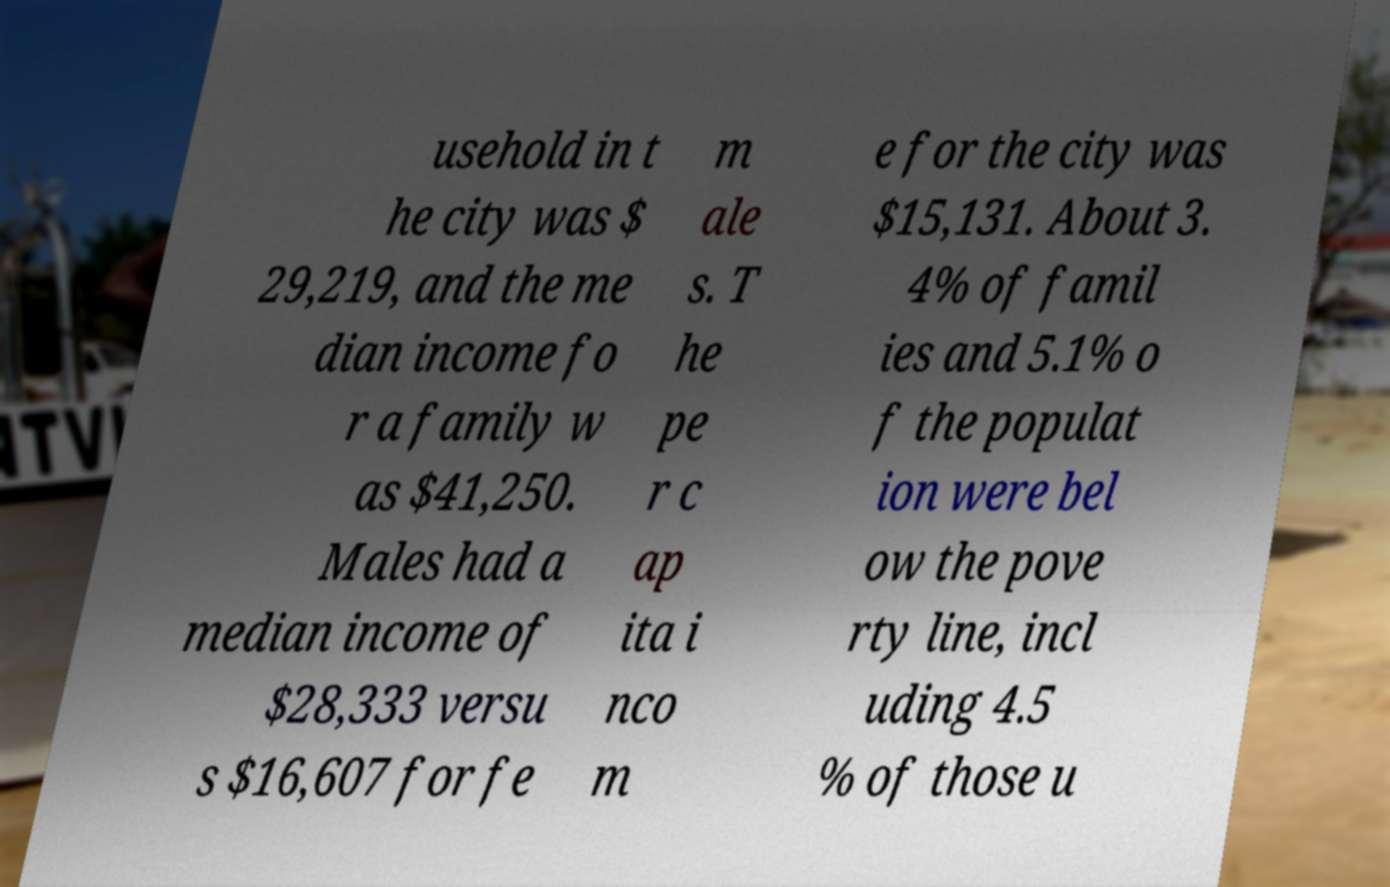For documentation purposes, I need the text within this image transcribed. Could you provide that? usehold in t he city was $ 29,219, and the me dian income fo r a family w as $41,250. Males had a median income of $28,333 versu s $16,607 for fe m ale s. T he pe r c ap ita i nco m e for the city was $15,131. About 3. 4% of famil ies and 5.1% o f the populat ion were bel ow the pove rty line, incl uding 4.5 % of those u 